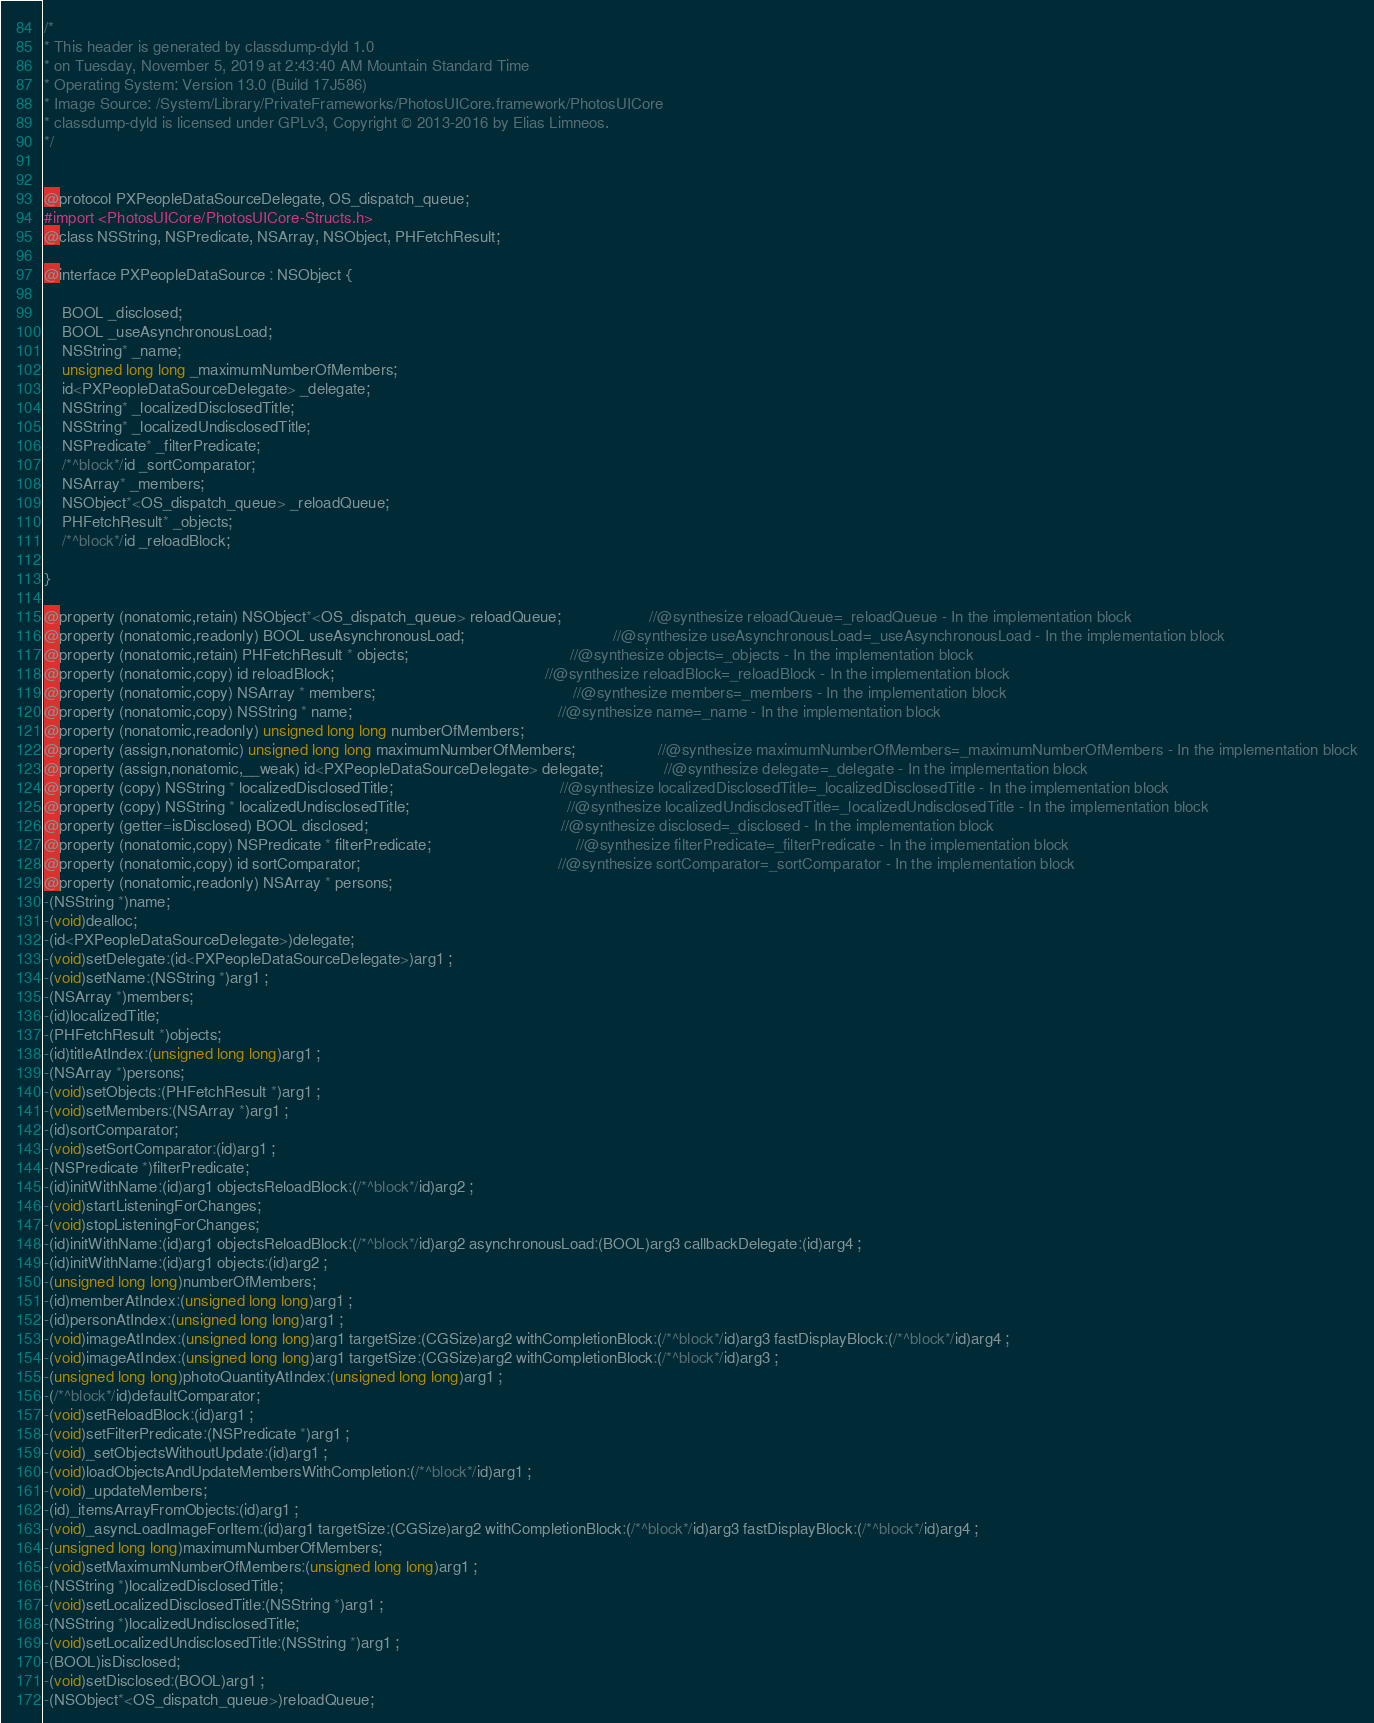Convert code to text. <code><loc_0><loc_0><loc_500><loc_500><_C_>/*
* This header is generated by classdump-dyld 1.0
* on Tuesday, November 5, 2019 at 2:43:40 AM Mountain Standard Time
* Operating System: Version 13.0 (Build 17J586)
* Image Source: /System/Library/PrivateFrameworks/PhotosUICore.framework/PhotosUICore
* classdump-dyld is licensed under GPLv3, Copyright © 2013-2016 by Elias Limneos.
*/


@protocol PXPeopleDataSourceDelegate, OS_dispatch_queue;
#import <PhotosUICore/PhotosUICore-Structs.h>
@class NSString, NSPredicate, NSArray, NSObject, PHFetchResult;

@interface PXPeopleDataSource : NSObject {

	BOOL _disclosed;
	BOOL _useAsynchronousLoad;
	NSString* _name;
	unsigned long long _maximumNumberOfMembers;
	id<PXPeopleDataSourceDelegate> _delegate;
	NSString* _localizedDisclosedTitle;
	NSString* _localizedUndisclosedTitle;
	NSPredicate* _filterPredicate;
	/*^block*/id _sortComparator;
	NSArray* _members;
	NSObject*<OS_dispatch_queue> _reloadQueue;
	PHFetchResult* _objects;
	/*^block*/id _reloadBlock;

}

@property (nonatomic,retain) NSObject*<OS_dispatch_queue> reloadQueue;                    //@synthesize reloadQueue=_reloadQueue - In the implementation block
@property (nonatomic,readonly) BOOL useAsynchronousLoad;                                  //@synthesize useAsynchronousLoad=_useAsynchronousLoad - In the implementation block
@property (nonatomic,retain) PHFetchResult * objects;                                     //@synthesize objects=_objects - In the implementation block
@property (nonatomic,copy) id reloadBlock;                                                //@synthesize reloadBlock=_reloadBlock - In the implementation block
@property (nonatomic,copy) NSArray * members;                                             //@synthesize members=_members - In the implementation block
@property (nonatomic,copy) NSString * name;                                               //@synthesize name=_name - In the implementation block
@property (nonatomic,readonly) unsigned long long numberOfMembers; 
@property (assign,nonatomic) unsigned long long maximumNumberOfMembers;                   //@synthesize maximumNumberOfMembers=_maximumNumberOfMembers - In the implementation block
@property (assign,nonatomic,__weak) id<PXPeopleDataSourceDelegate> delegate;              //@synthesize delegate=_delegate - In the implementation block
@property (copy) NSString * localizedDisclosedTitle;                                      //@synthesize localizedDisclosedTitle=_localizedDisclosedTitle - In the implementation block
@property (copy) NSString * localizedUndisclosedTitle;                                    //@synthesize localizedUndisclosedTitle=_localizedUndisclosedTitle - In the implementation block
@property (getter=isDisclosed) BOOL disclosed;                                            //@synthesize disclosed=_disclosed - In the implementation block
@property (nonatomic,copy) NSPredicate * filterPredicate;                                 //@synthesize filterPredicate=_filterPredicate - In the implementation block
@property (nonatomic,copy) id sortComparator;                                             //@synthesize sortComparator=_sortComparator - In the implementation block
@property (nonatomic,readonly) NSArray * persons; 
-(NSString *)name;
-(void)dealloc;
-(id<PXPeopleDataSourceDelegate>)delegate;
-(void)setDelegate:(id<PXPeopleDataSourceDelegate>)arg1 ;
-(void)setName:(NSString *)arg1 ;
-(NSArray *)members;
-(id)localizedTitle;
-(PHFetchResult *)objects;
-(id)titleAtIndex:(unsigned long long)arg1 ;
-(NSArray *)persons;
-(void)setObjects:(PHFetchResult *)arg1 ;
-(void)setMembers:(NSArray *)arg1 ;
-(id)sortComparator;
-(void)setSortComparator:(id)arg1 ;
-(NSPredicate *)filterPredicate;
-(id)initWithName:(id)arg1 objectsReloadBlock:(/*^block*/id)arg2 ;
-(void)startListeningForChanges;
-(void)stopListeningForChanges;
-(id)initWithName:(id)arg1 objectsReloadBlock:(/*^block*/id)arg2 asynchronousLoad:(BOOL)arg3 callbackDelegate:(id)arg4 ;
-(id)initWithName:(id)arg1 objects:(id)arg2 ;
-(unsigned long long)numberOfMembers;
-(id)memberAtIndex:(unsigned long long)arg1 ;
-(id)personAtIndex:(unsigned long long)arg1 ;
-(void)imageAtIndex:(unsigned long long)arg1 targetSize:(CGSize)arg2 withCompletionBlock:(/*^block*/id)arg3 fastDisplayBlock:(/*^block*/id)arg4 ;
-(void)imageAtIndex:(unsigned long long)arg1 targetSize:(CGSize)arg2 withCompletionBlock:(/*^block*/id)arg3 ;
-(unsigned long long)photoQuantityAtIndex:(unsigned long long)arg1 ;
-(/*^block*/id)defaultComparator;
-(void)setReloadBlock:(id)arg1 ;
-(void)setFilterPredicate:(NSPredicate *)arg1 ;
-(void)_setObjectsWithoutUpdate:(id)arg1 ;
-(void)loadObjectsAndUpdateMembersWithCompletion:(/*^block*/id)arg1 ;
-(void)_updateMembers;
-(id)_itemsArrayFromObjects:(id)arg1 ;
-(void)_asyncLoadImageForItem:(id)arg1 targetSize:(CGSize)arg2 withCompletionBlock:(/*^block*/id)arg3 fastDisplayBlock:(/*^block*/id)arg4 ;
-(unsigned long long)maximumNumberOfMembers;
-(void)setMaximumNumberOfMembers:(unsigned long long)arg1 ;
-(NSString *)localizedDisclosedTitle;
-(void)setLocalizedDisclosedTitle:(NSString *)arg1 ;
-(NSString *)localizedUndisclosedTitle;
-(void)setLocalizedUndisclosedTitle:(NSString *)arg1 ;
-(BOOL)isDisclosed;
-(void)setDisclosed:(BOOL)arg1 ;
-(NSObject*<OS_dispatch_queue>)reloadQueue;</code> 